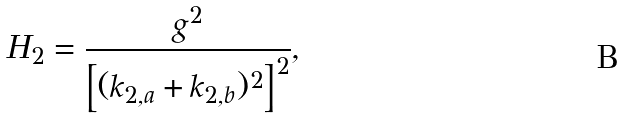Convert formula to latex. <formula><loc_0><loc_0><loc_500><loc_500>H _ { 2 } = \frac { g ^ { 2 } } { \left [ ( k _ { 2 , a } + k _ { 2 , b } ) ^ { 2 } \right ] ^ { 2 } } ,</formula> 